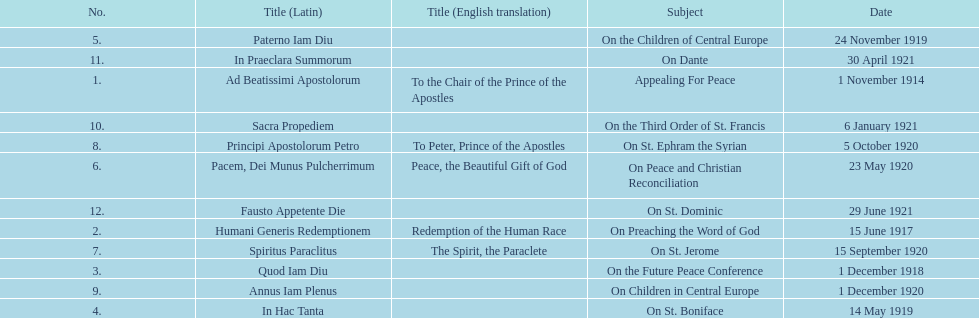After december 1, 1918, on which date was the next encyclical released? 14 May 1919. 